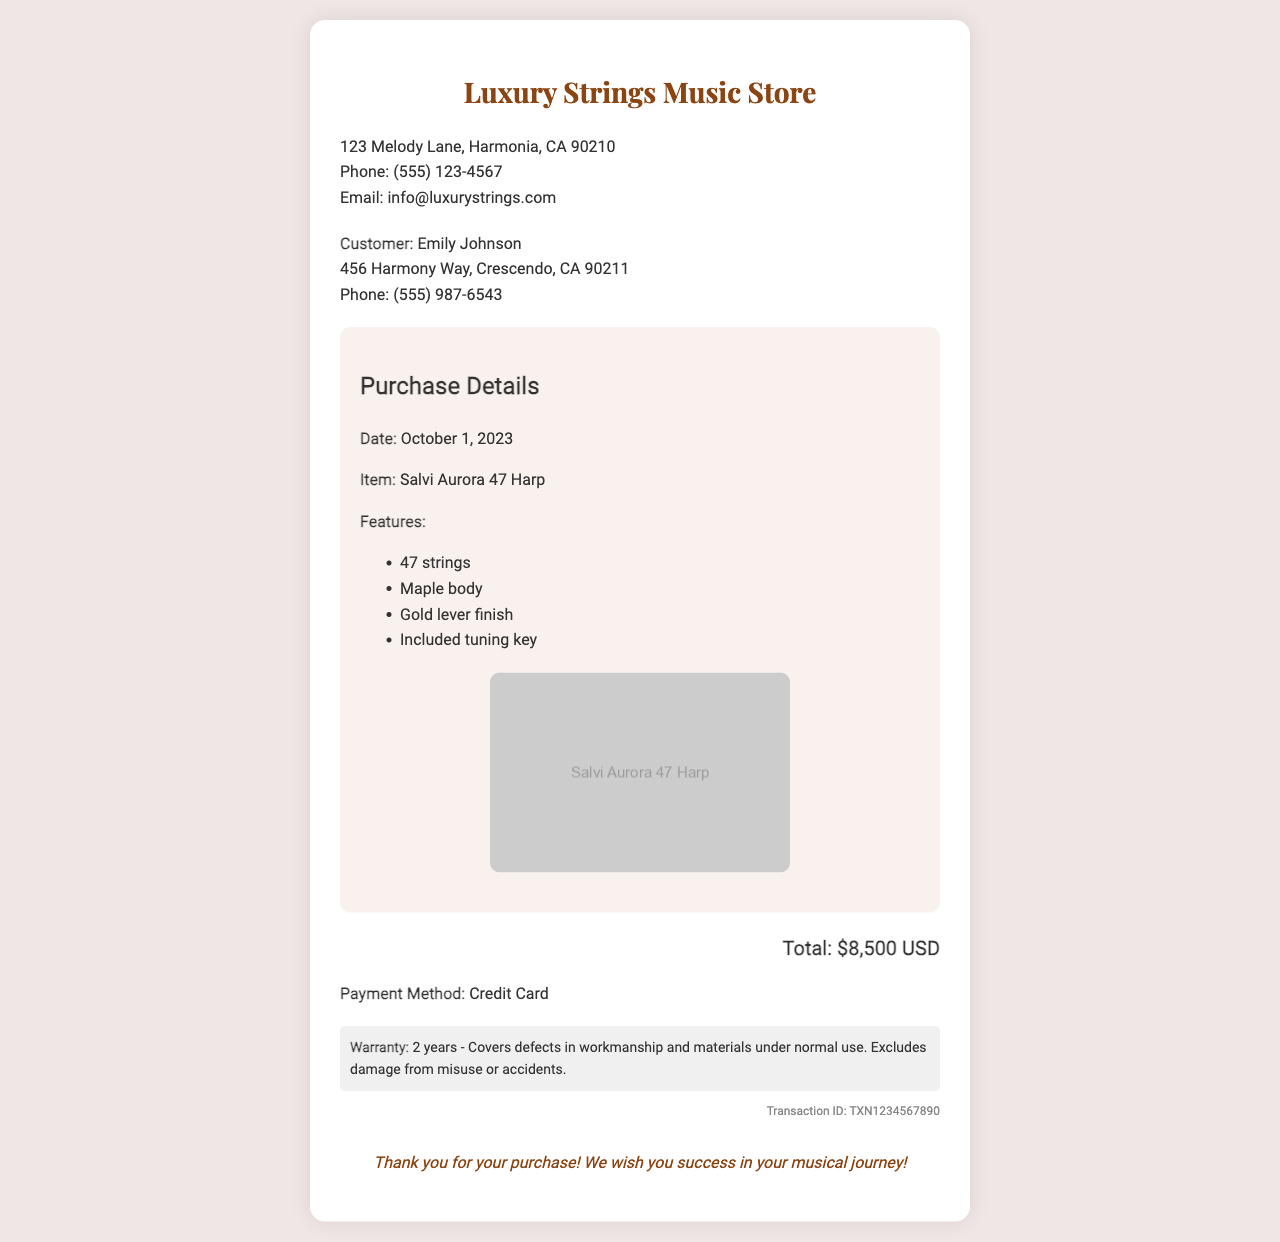What is the name of the harp purchased? The harp purchased is identified in the document as the Salvi Aurora 47 Harp.
Answer: Salvi Aurora 47 Harp What is the price of the harp? The total price for the harp purchase is clearly stated in the document as $8,500 USD.
Answer: $8,500 USD What date was the harp purchased? The date of purchase is mentioned in the document, which is October 1, 2023.
Answer: October 1, 2023 How many strings does the harp have? The document specifies that the harp has 47 strings, which is one of its features.
Answer: 47 strings What warranty period is provided for the harp? The document indicates that the warranty period for the harp is 2 years, covering defects in workmanship and materials.
Answer: 2 years What is the payment method used for the purchase? The method of payment is stated in the document as being made by credit card.
Answer: Credit Card Where is the music store located? The location of the music store is provided in the document as 123 Melody Lane, Harmonia, CA 90210.
Answer: 123 Melody Lane, Harmonia, CA 90210 What type of damage is excluded from the warranty? The document specifies that damage from misuse or accidents is excluded from the warranty coverage.
Answer: Misuse or accidents 